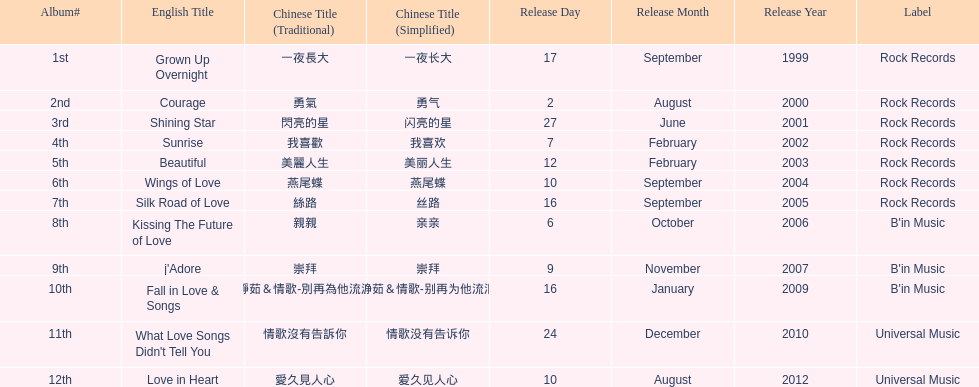What label was she working with before universal music? B'in Music. I'm looking to parse the entire table for insights. Could you assist me with that? {'header': ['Album#', 'English Title', 'Chinese Title (Traditional)', 'Chinese Title (Simplified)', 'Release Day', 'Release Month', 'Release Year', 'Label'], 'rows': [['1st', 'Grown Up Overnight', '一夜長大', '一夜长大', '17', 'September', '1999', 'Rock Records'], ['2nd', 'Courage', '勇氣', '勇气', '2', 'August', '2000', 'Rock Records'], ['3rd', 'Shining Star', '閃亮的星', '闪亮的星', '27', 'June', '2001', 'Rock Records'], ['4th', 'Sunrise', '我喜歡', '我喜欢', '7', 'February', '2002', 'Rock Records'], ['5th', 'Beautiful', '美麗人生', '美丽人生', '12', 'February', '2003', 'Rock Records'], ['6th', 'Wings of Love', '燕尾蝶', '燕尾蝶', '10', 'September', '2004', 'Rock Records'], ['7th', 'Silk Road of Love', '絲路', '丝路', '16', 'September', '2005', 'Rock Records'], ['8th', 'Kissing The Future of Love', '親親', '亲亲', '6', 'October', '2006', "B'in Music"], ['9th', "j'Adore", '崇拜', '崇拜', '9', 'November', '2007', "B'in Music"], ['10th', 'Fall in Love & Songs', '靜茹＆情歌-別再為他流淚', '静茹＆情歌-别再为他流泪', '16', 'January', '2009', "B'in Music"], ['11th', "What Love Songs Didn't Tell You", '情歌沒有告訴你', '情歌没有告诉你', '24', 'December', '2010', 'Universal Music'], ['12th', 'Love in Heart', '愛久見人心', '爱久见人心', '10', 'August', '2012', 'Universal Music']]} 